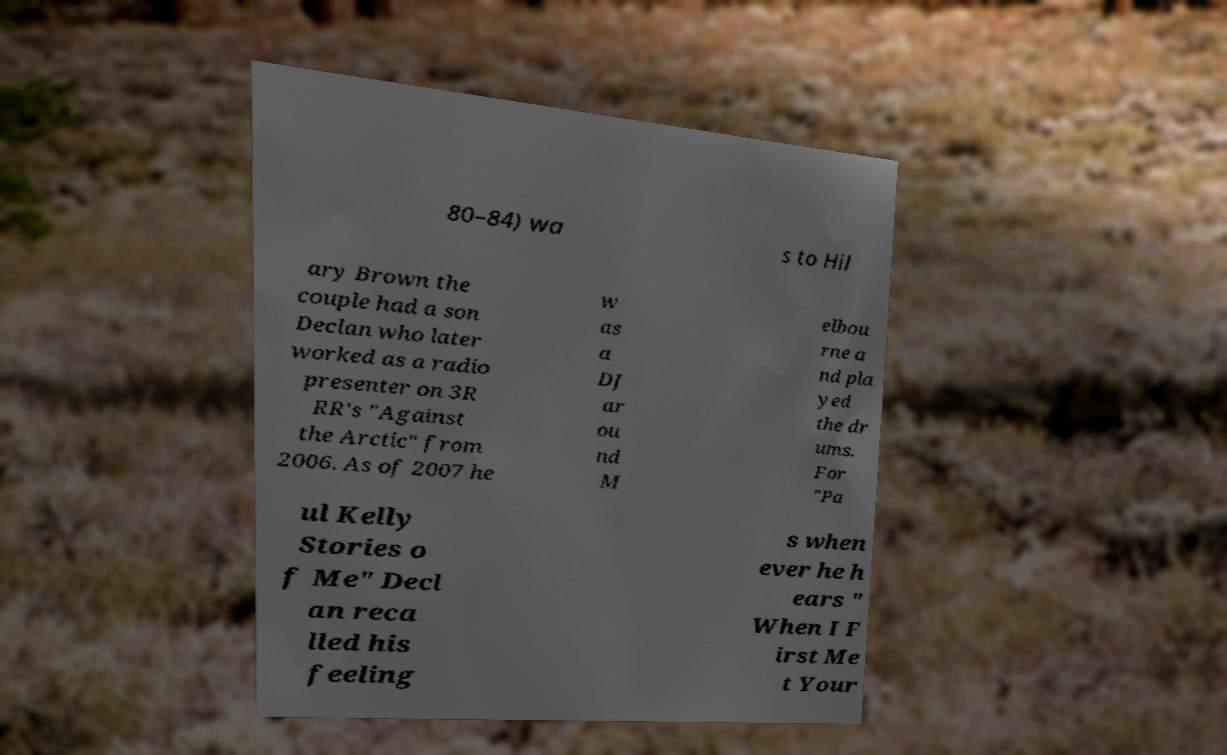I need the written content from this picture converted into text. Can you do that? 80–84) wa s to Hil ary Brown the couple had a son Declan who later worked as a radio presenter on 3R RR's "Against the Arctic" from 2006. As of 2007 he w as a DJ ar ou nd M elbou rne a nd pla yed the dr ums. For "Pa ul Kelly Stories o f Me" Decl an reca lled his feeling s when ever he h ears " When I F irst Me t Your 